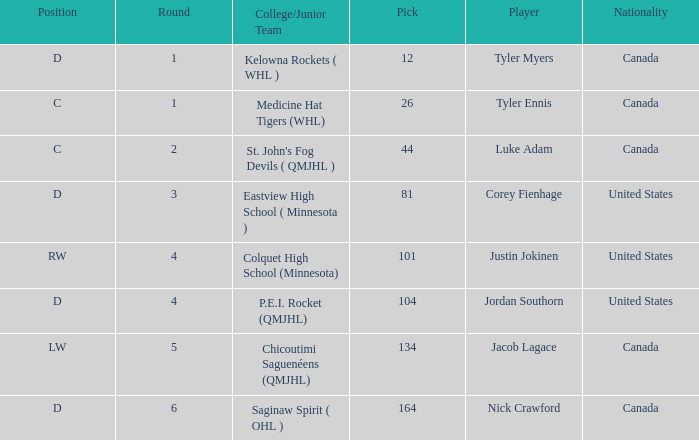What is the college/junior team of player tyler myers, who has a pick less than 44? Kelowna Rockets ( WHL ). 